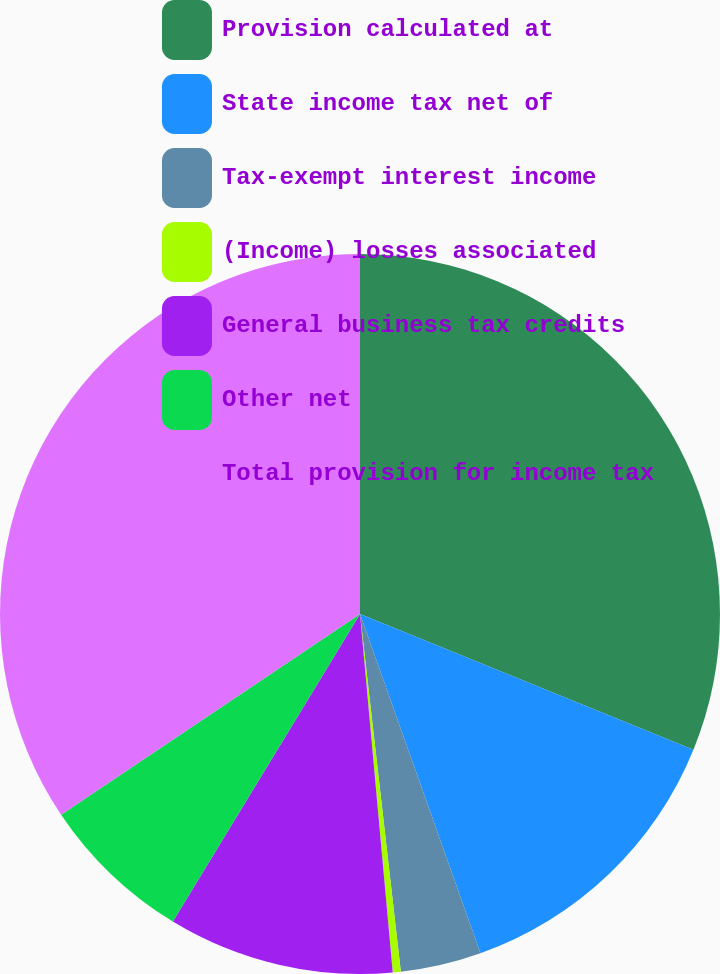<chart> <loc_0><loc_0><loc_500><loc_500><pie_chart><fcel>Provision calculated at<fcel>State income tax net of<fcel>Tax-exempt interest income<fcel>(Income) losses associated<fcel>General business tax credits<fcel>Other net<fcel>Total provision for income tax<nl><fcel>31.15%<fcel>13.42%<fcel>3.62%<fcel>0.36%<fcel>10.15%<fcel>6.89%<fcel>34.41%<nl></chart> 